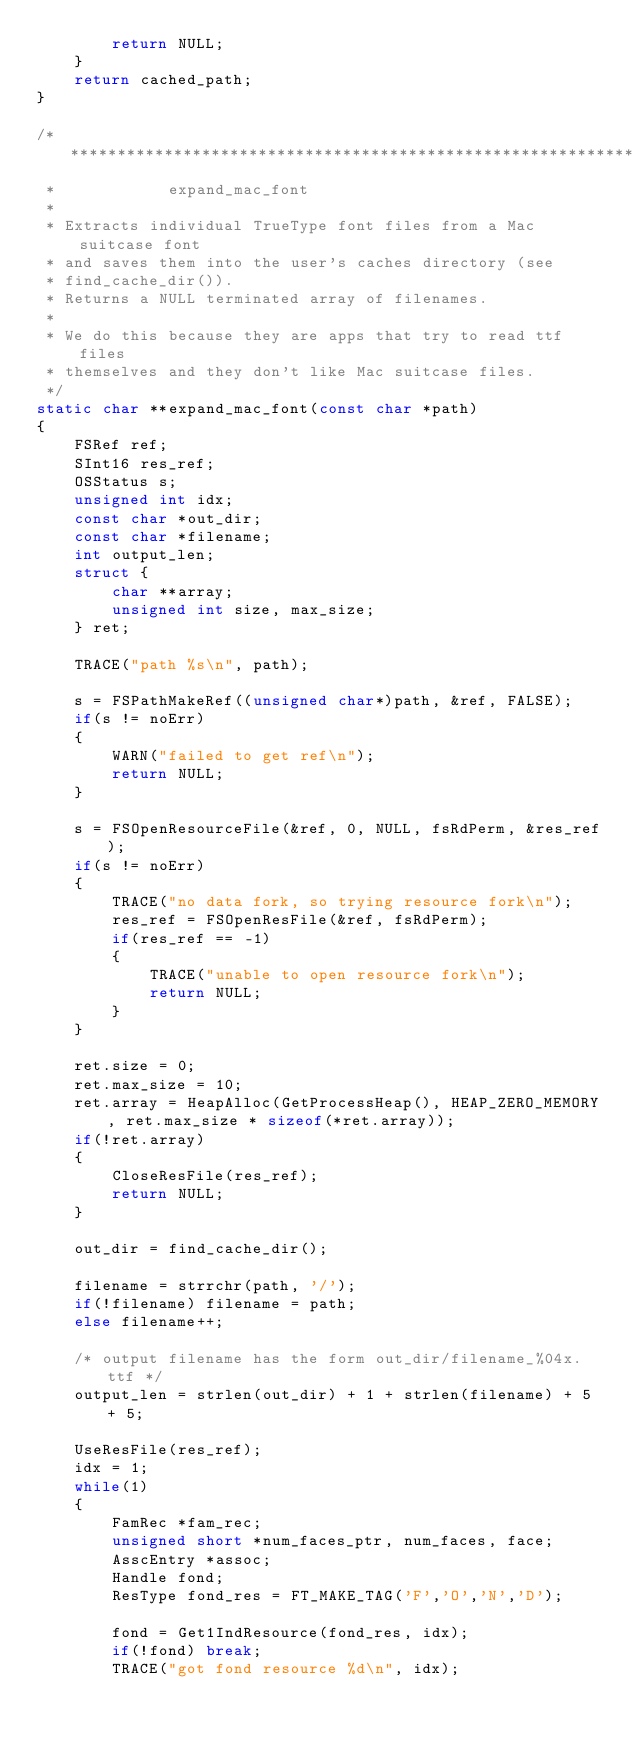Convert code to text. <code><loc_0><loc_0><loc_500><loc_500><_C_>        return NULL;
    }
    return cached_path;
}

/******************************************************************
 *            expand_mac_font
 *
 * Extracts individual TrueType font files from a Mac suitcase font
 * and saves them into the user's caches directory (see
 * find_cache_dir()).
 * Returns a NULL terminated array of filenames.
 *
 * We do this because they are apps that try to read ttf files
 * themselves and they don't like Mac suitcase files.
 */
static char **expand_mac_font(const char *path)
{
    FSRef ref;
    SInt16 res_ref;
    OSStatus s;
    unsigned int idx;
    const char *out_dir;
    const char *filename;
    int output_len;
    struct {
        char **array;
        unsigned int size, max_size;
    } ret;

    TRACE("path %s\n", path);

    s = FSPathMakeRef((unsigned char*)path, &ref, FALSE);
    if(s != noErr)
    {
        WARN("failed to get ref\n");
        return NULL;
    }

    s = FSOpenResourceFile(&ref, 0, NULL, fsRdPerm, &res_ref);
    if(s != noErr)
    {
        TRACE("no data fork, so trying resource fork\n");
        res_ref = FSOpenResFile(&ref, fsRdPerm);
        if(res_ref == -1)
        {
            TRACE("unable to open resource fork\n");
            return NULL;
        }
    }

    ret.size = 0;
    ret.max_size = 10;
    ret.array = HeapAlloc(GetProcessHeap(), HEAP_ZERO_MEMORY, ret.max_size * sizeof(*ret.array));
    if(!ret.array)
    {
        CloseResFile(res_ref);
        return NULL;
    }

    out_dir = find_cache_dir();

    filename = strrchr(path, '/');
    if(!filename) filename = path;
    else filename++;

    /* output filename has the form out_dir/filename_%04x.ttf */
    output_len = strlen(out_dir) + 1 + strlen(filename) + 5 + 5;

    UseResFile(res_ref);
    idx = 1;
    while(1)
    {
        FamRec *fam_rec;
        unsigned short *num_faces_ptr, num_faces, face;
        AsscEntry *assoc;
        Handle fond;
        ResType fond_res = FT_MAKE_TAG('F','O','N','D');

        fond = Get1IndResource(fond_res, idx);
        if(!fond) break;
        TRACE("got fond resource %d\n", idx);</code> 